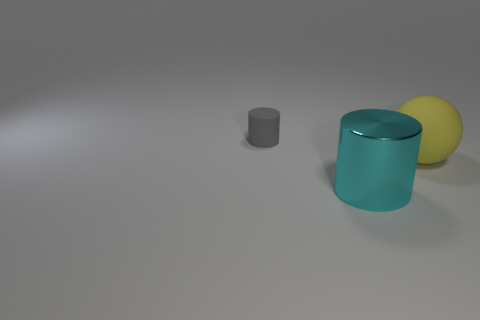Is there any other thing that has the same size as the gray matte thing?
Provide a short and direct response. No. What is the material of the cylinder that is in front of the large yellow ball?
Provide a short and direct response. Metal. Are there any other things that are the same shape as the big matte object?
Your response must be concise. No. How many metallic objects are either brown blocks or large cyan things?
Your answer should be compact. 1. Is the number of things that are behind the metallic cylinder less than the number of large green matte blocks?
Offer a very short reply. No. There is a rubber object on the right side of the matte object that is behind the large thing that is to the right of the cyan metallic cylinder; what is its shape?
Your response must be concise. Sphere. Is the number of purple spheres greater than the number of tiny gray objects?
Ensure brevity in your answer.  No. What number of other objects are there of the same material as the tiny gray thing?
Keep it short and to the point. 1. What number of things are either tiny brown shiny balls or cyan shiny objects that are on the right side of the small gray cylinder?
Give a very brief answer. 1. Is the number of big metallic cylinders less than the number of gray shiny cylinders?
Offer a very short reply. No. 